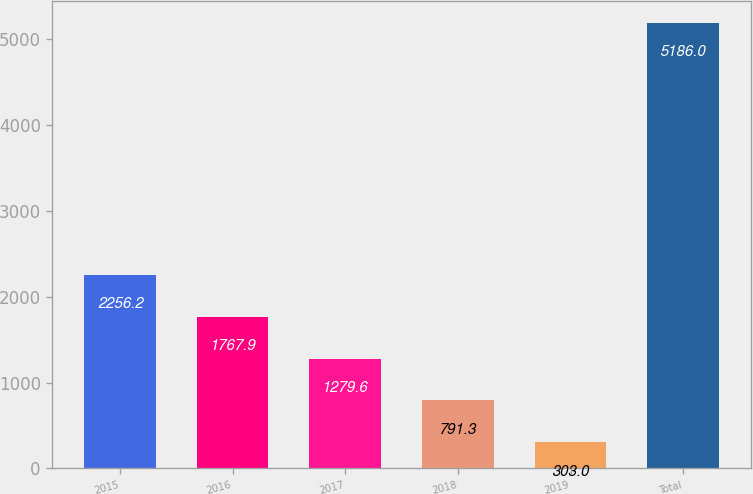Convert chart to OTSL. <chart><loc_0><loc_0><loc_500><loc_500><bar_chart><fcel>2015<fcel>2016<fcel>2017<fcel>2018<fcel>2019<fcel>Total<nl><fcel>2256.2<fcel>1767.9<fcel>1279.6<fcel>791.3<fcel>303<fcel>5186<nl></chart> 